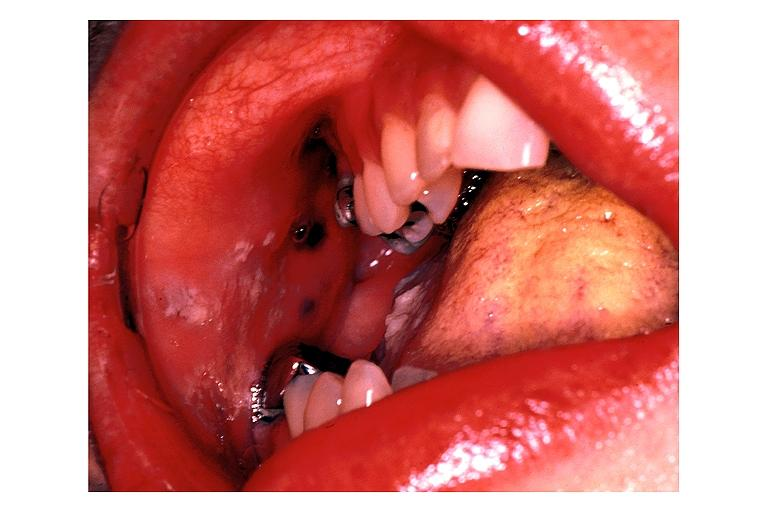where is this?
Answer the question using a single word or phrase. Oral 